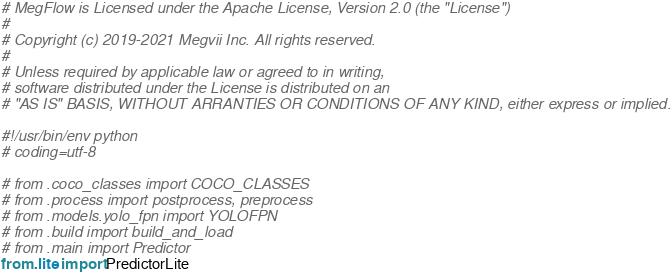<code> <loc_0><loc_0><loc_500><loc_500><_Python_># MegFlow is Licensed under the Apache License, Version 2.0 (the "License")
#
# Copyright (c) 2019-2021 Megvii Inc. All rights reserved.
#
# Unless required by applicable law or agreed to in writing,
# software distributed under the License is distributed on an
# "AS IS" BASIS, WITHOUT ARRANTIES OR CONDITIONS OF ANY KIND, either express or implied.

#!/usr/bin/env python
# coding=utf-8

# from .coco_classes import COCO_CLASSES
# from .process import postprocess, preprocess
# from .models.yolo_fpn import YOLOFPN
# from .build import build_and_load
# from .main import Predictor
from .lite import PredictorLite
</code> 